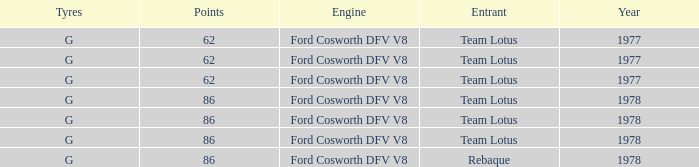What is the Motor that has a Focuses bigger than 62, and a Participant of rebaque? Ford Cosworth DFV V8. 